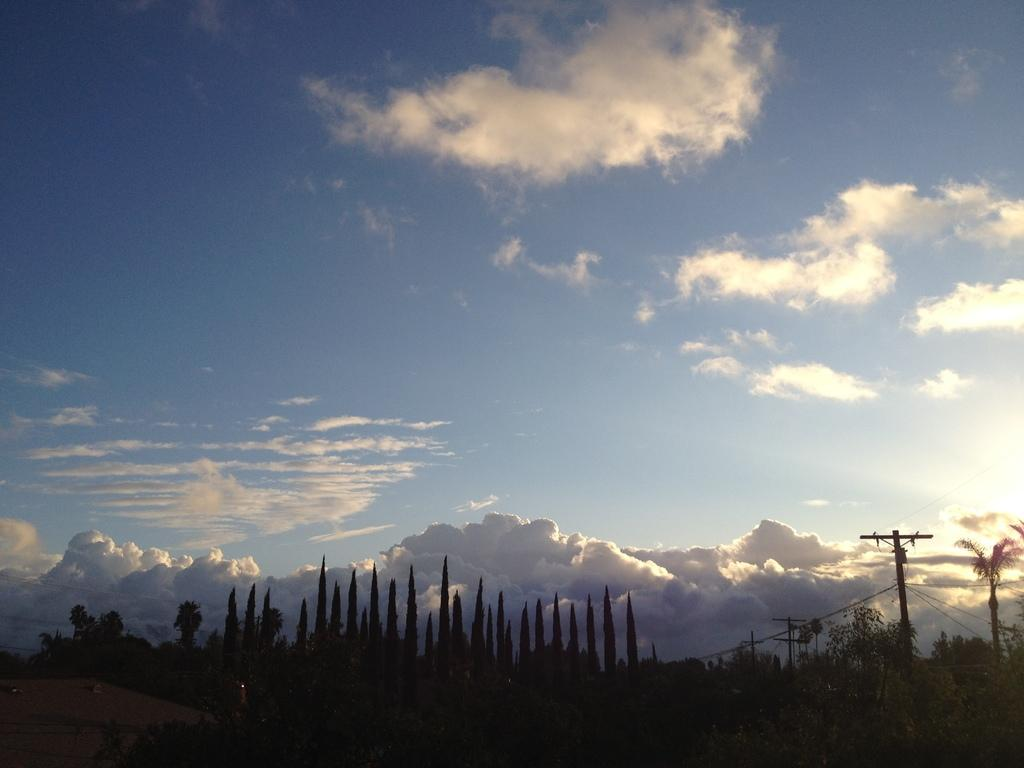What can be seen in the dark area of the image? Trees, current poles, and wires are present in the dark area of the image. What is visible in the background of the image? The sky with clouds is visible in the background. What type of cushion is being used in the office setting in the image? There is no office setting or cushion present in the image. 